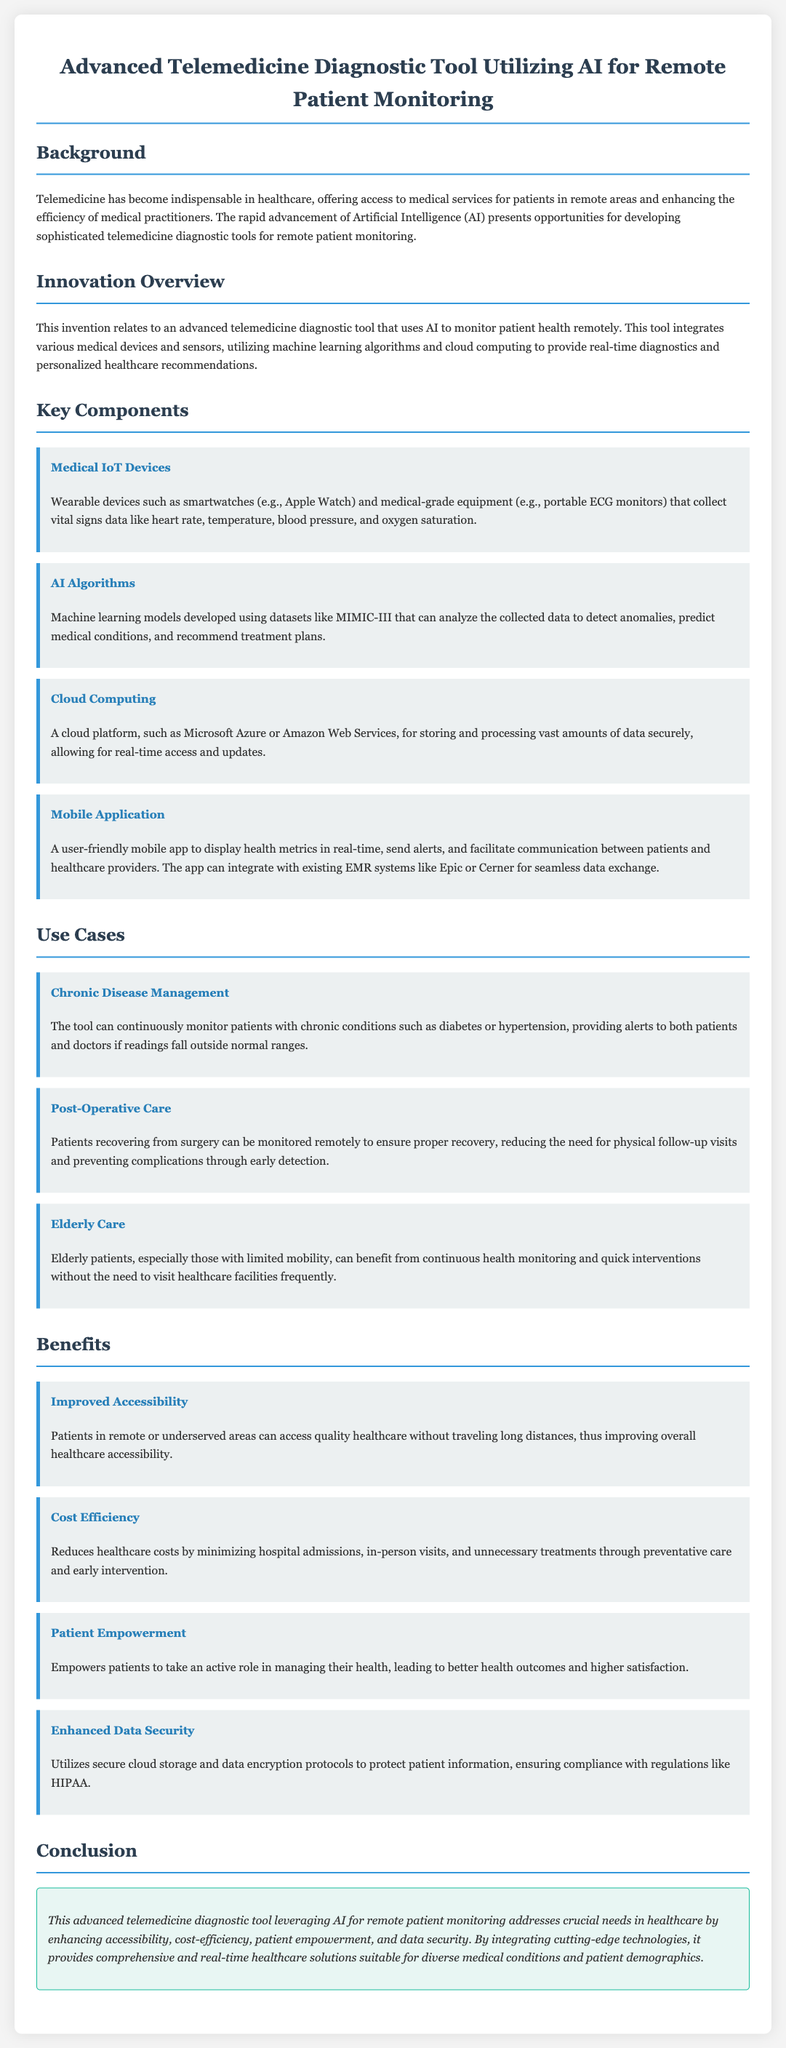What is the main technology featured in the tool? The tool primarily utilizes Artificial Intelligence (AI) for monitoring patient health remotely.
Answer: Artificial Intelligence What is one use case of the tool for elderly patients? The document states that elderly patients can benefit from continuous health monitoring and quick interventions without frequent visits.
Answer: Continuous health monitoring What does the mobile application do? The mobile app displays health metrics in real-time, sends alerts, and facilitates communication between patients and healthcare providers.
Answer: Displays health metrics What is one benefit of improved accessibility? Patients in remote areas can access quality healthcare without traveling long distances.
Answer: Access quality healthcare Which cloud platform is mentioned for data storage? The document refers to cloud platforms like Microsoft Azure or Amazon Web Services for secure data storage.
Answer: Microsoft Azure How does the tool impact healthcare costs? The tool reduces healthcare costs by minimizing hospital admissions and unnecessary treatments.
Answer: Minimizing hospital admissions What type of devices does the tool integrate? The tool integrates wearable devices such as smartwatches and medical-grade equipment.
Answer: Wearable devices What medical condition can be managed with the tool? The tool can monitor patients with chronic conditions such as diabetes or hypertension.
Answer: Diabetes What regulatory compliance is emphasized in the document? The document mentions compliance with regulations like HIPAA for data security.
Answer: HIPAA 